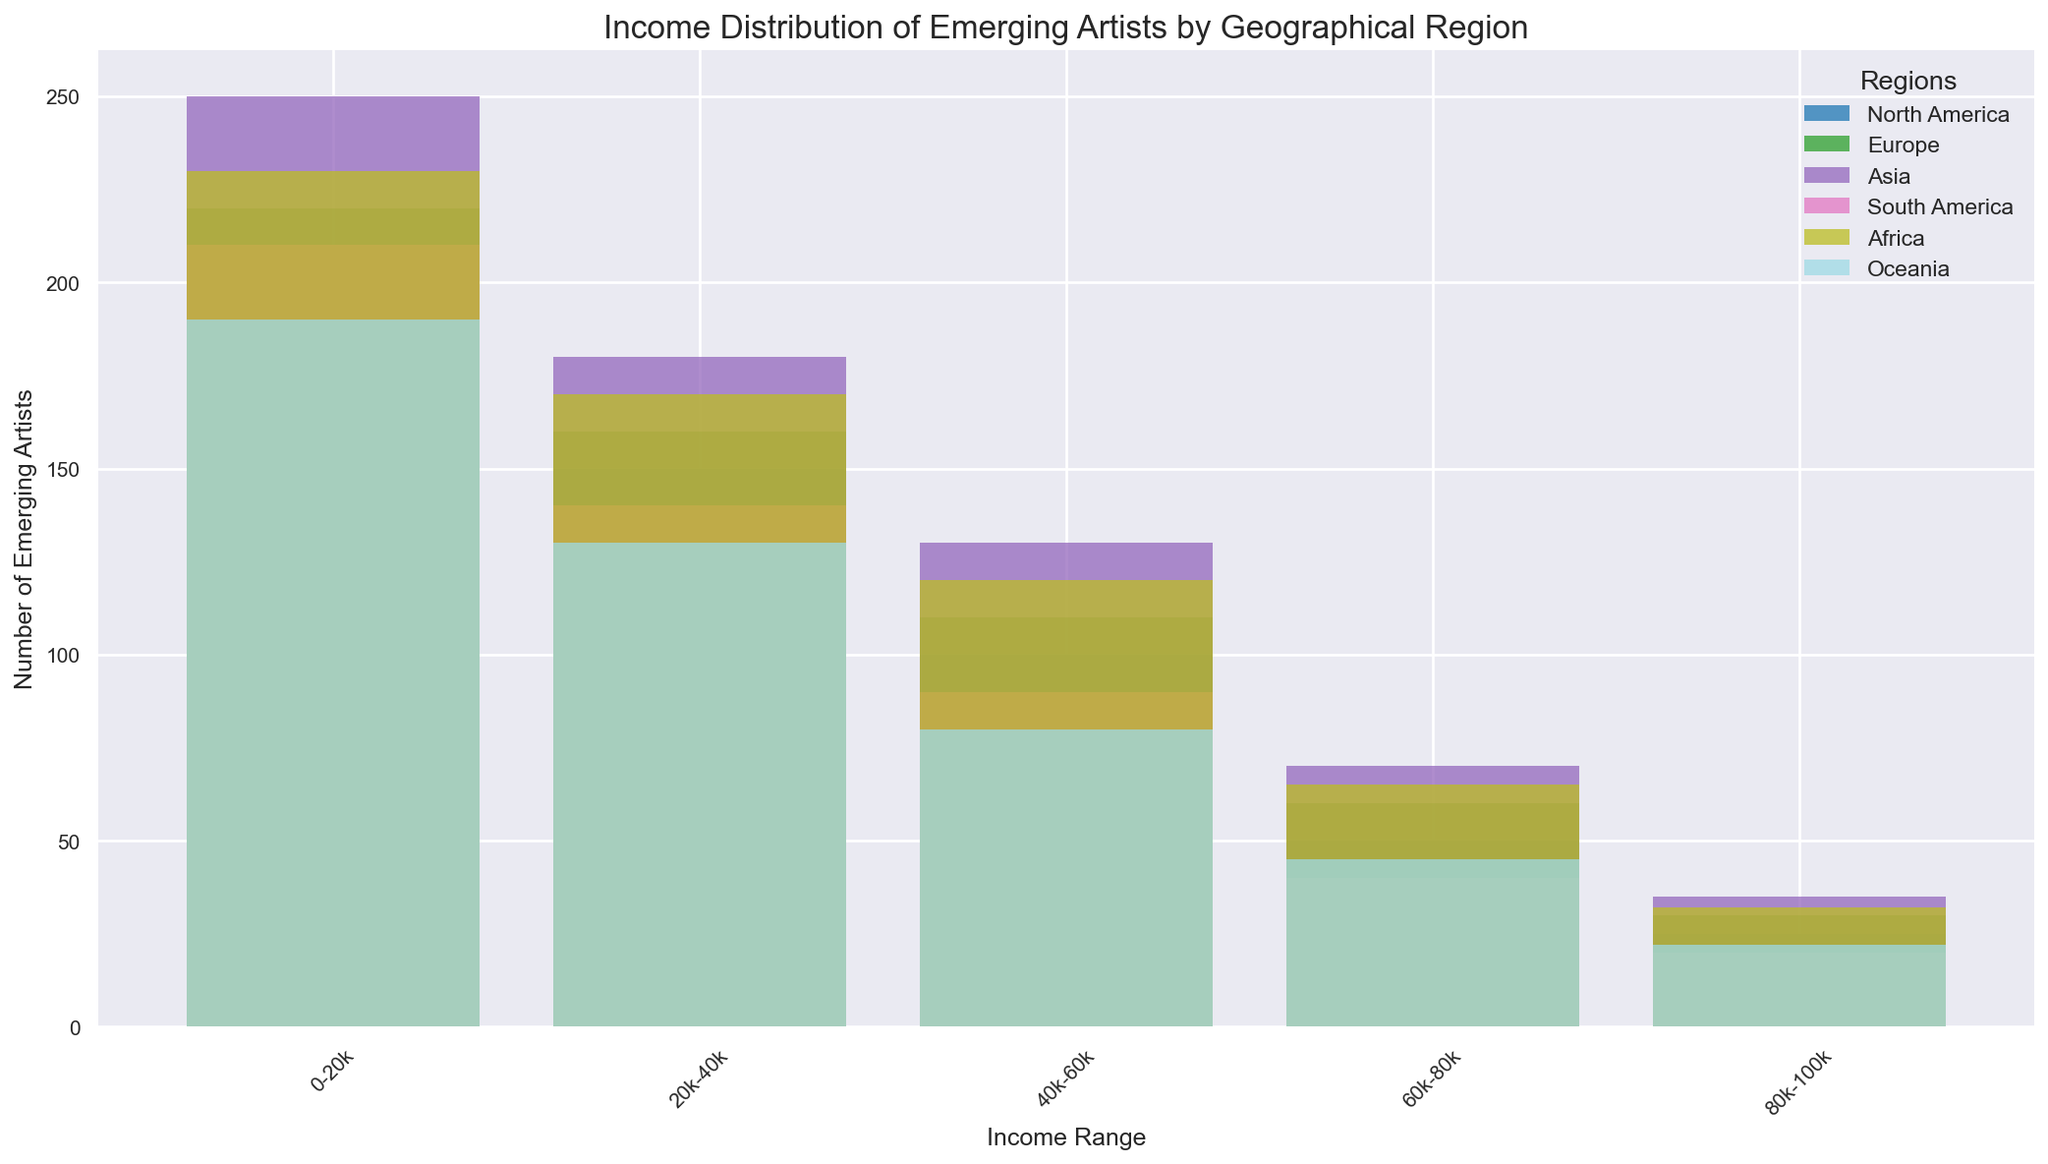What is the total number of emerging artists in North America with an income less than 40k? Summing the number of emerging artists in North America with incomes in the ranges 0-20k and 20k-40k: 200 + 150
Answer: 350 Which region has the most emerging artists in the 40k-60k income range? Comparing the number of emerging artists in the 40k-60k income range across different regions, the counts are: North America (100), Europe (110), Asia (130), South America (90), Africa (120), and Oceania (80). Asia has the highest count.
Answer: Asia How many more emerging artists in the 0-20k income range does Asia have compared to Oceania? Subtracting the number of emerging artists in Oceania from those in Asia in the 0-20k income range: 250 - 190
Answer: 60 What is the income range where Europe has the highest number of emerging artists? In Europe, the counts are 220 (0-20k), 160 (20k-40k), 110 (40k-60k), 60 (60k-80k), and 30 (80k-100k). The highest count is 220 in the 0-20k range.
Answer: 0-20k Which region has the least number of emerging artists in the 80k-100k income range? Comparing the number of emerging artists in the 80k-100k income range across regions: North America (25), Europe (30), Asia (35), South America (20), Africa (32), and Oceania (22). South America has the least.
Answer: South America In which income range does Africa have more emerging artists than North America? Comparing counts for Africa and North America across income ranges: 0-20k (230 vs 200), 20k-40k (170 vs 150), 40k-60k (120 vs 100), 60k-80k (65 vs 50), 80k-100k (32 vs 25). Africa has more emerging artists in all income ranges.
Answer: All ranges What is the difference in the number of emerging artists in Europe and South America for the 20k-40k income range? Subtracting the number of emerging artists in South America from those in Europe in the 20k-40k income range: 160 - 140
Answer: 20 Which region has the steepest decrease in the number of emerging artists from the 0-20k range to the 80k-100k range? Calculating the decrease for each region: North America (200 to 25), Europe (220 to 30), Asia (250 to 35), South America (210 to 20), Africa (230 to 32), Oceania (190 to 22). North America's decrease is 175, Europe's is 190, Asia's is 215, South America's is 190, Africa's is 198, and Oceania's is 168. Asia has the steepest decrease.
Answer: Asia How does the income distribution of emerging artists in South America compare to that in North America for the 60k-80k income range? Comparing the number of emerging artists in the 60k-80k income range: South America has 40, North America has 50. North America has more artists in this range.
Answer: North America Which two regions have similar numbers of emerging artists in the 20k-40k income range? Comparing counts in the 20k-40k range: North America (150), Europe (160), Asia (180), South America (140), Africa (170), and Oceania (130). North America and South America's counts are close (150 vs 140).
Answer: North America and South America 